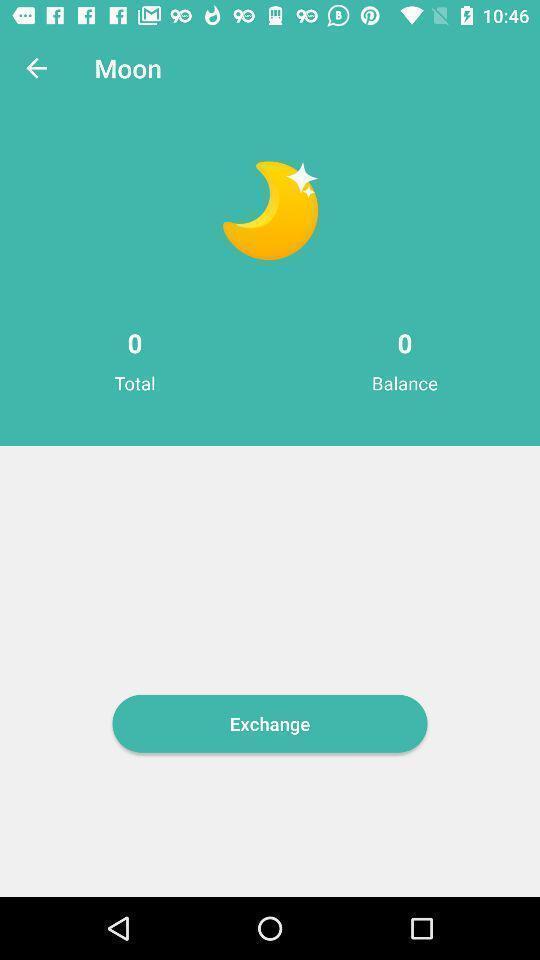Provide a textual representation of this image. Screen shows information about an app. 